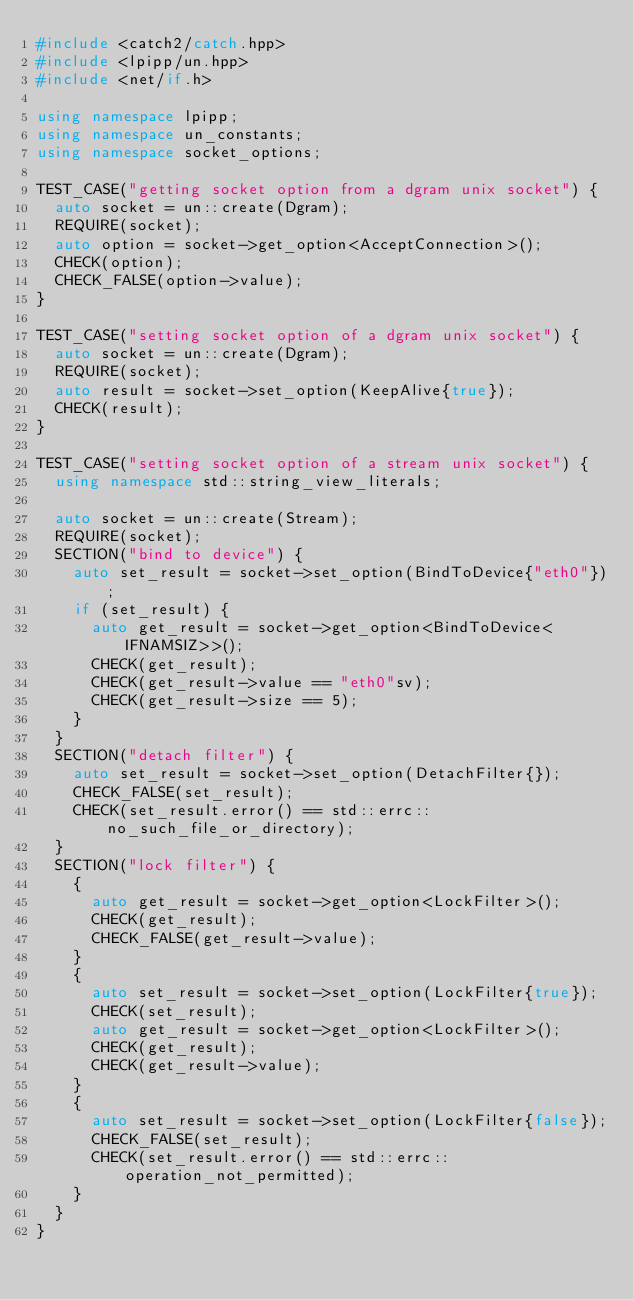Convert code to text. <code><loc_0><loc_0><loc_500><loc_500><_C++_>#include <catch2/catch.hpp>
#include <lpipp/un.hpp>
#include <net/if.h>

using namespace lpipp;
using namespace un_constants;
using namespace socket_options;

TEST_CASE("getting socket option from a dgram unix socket") {
  auto socket = un::create(Dgram);
  REQUIRE(socket);
  auto option = socket->get_option<AcceptConnection>();
  CHECK(option);
  CHECK_FALSE(option->value);
}

TEST_CASE("setting socket option of a dgram unix socket") {
  auto socket = un::create(Dgram);
  REQUIRE(socket);
  auto result = socket->set_option(KeepAlive{true});
  CHECK(result);
}

TEST_CASE("setting socket option of a stream unix socket") {
  using namespace std::string_view_literals;

  auto socket = un::create(Stream);
  REQUIRE(socket);
  SECTION("bind to device") {
    auto set_result = socket->set_option(BindToDevice{"eth0"});
    if (set_result) {
      auto get_result = socket->get_option<BindToDevice<IFNAMSIZ>>();
      CHECK(get_result);
      CHECK(get_result->value == "eth0"sv);
      CHECK(get_result->size == 5);
    }
  }
  SECTION("detach filter") {
    auto set_result = socket->set_option(DetachFilter{});
    CHECK_FALSE(set_result);
    CHECK(set_result.error() == std::errc::no_such_file_or_directory);
  }
  SECTION("lock filter") {
    {
      auto get_result = socket->get_option<LockFilter>();
      CHECK(get_result);
      CHECK_FALSE(get_result->value);
    }
    {
      auto set_result = socket->set_option(LockFilter{true});
      CHECK(set_result);
      auto get_result = socket->get_option<LockFilter>();
      CHECK(get_result);
      CHECK(get_result->value);
    }
    {
      auto set_result = socket->set_option(LockFilter{false});
      CHECK_FALSE(set_result);
      CHECK(set_result.error() == std::errc::operation_not_permitted);
    }
  }
}
</code> 